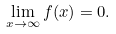Convert formula to latex. <formula><loc_0><loc_0><loc_500><loc_500>\lim _ { x \to \infty } f ( x ) & = 0 .</formula> 